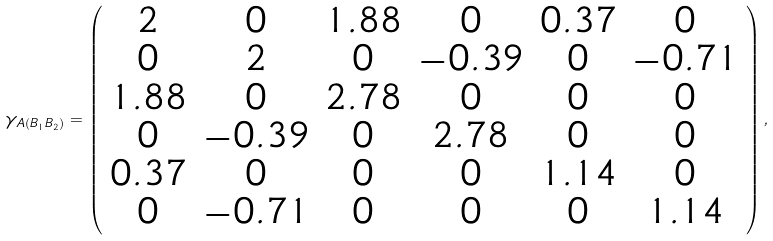<formula> <loc_0><loc_0><loc_500><loc_500>\gamma _ { A \left ( B _ { 1 } B _ { 2 } \right ) } = \left ( \begin{array} { c c c c c c } 2 & 0 & 1 . 8 8 & 0 & 0 . 3 7 & 0 \\ 0 & 2 & 0 & - 0 . 3 9 & 0 & - 0 . 7 1 \\ 1 . 8 8 & 0 & 2 . 7 8 & 0 & 0 & 0 \\ 0 & - 0 . 3 9 & 0 & 2 . 7 8 & 0 & 0 \\ 0 . 3 7 & 0 & 0 & 0 & 1 . 1 4 & 0 \\ 0 & - 0 . 7 1 & 0 & 0 & 0 & 1 . 1 4 \\ \end{array} \right ) ,</formula> 